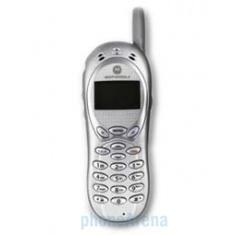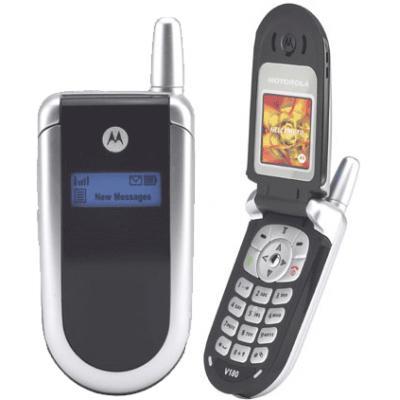The first image is the image on the left, the second image is the image on the right. For the images displayed, is the sentence "The left image features a phone style that does not flip up and has a short antenna on the top and a rectangular display on the front, and the right image includes a phone with its lid flipped up." factually correct? Answer yes or no. Yes. The first image is the image on the left, the second image is the image on the right. Given the left and right images, does the statement "A flip phone is in the open position in the image on the right." hold true? Answer yes or no. Yes. 